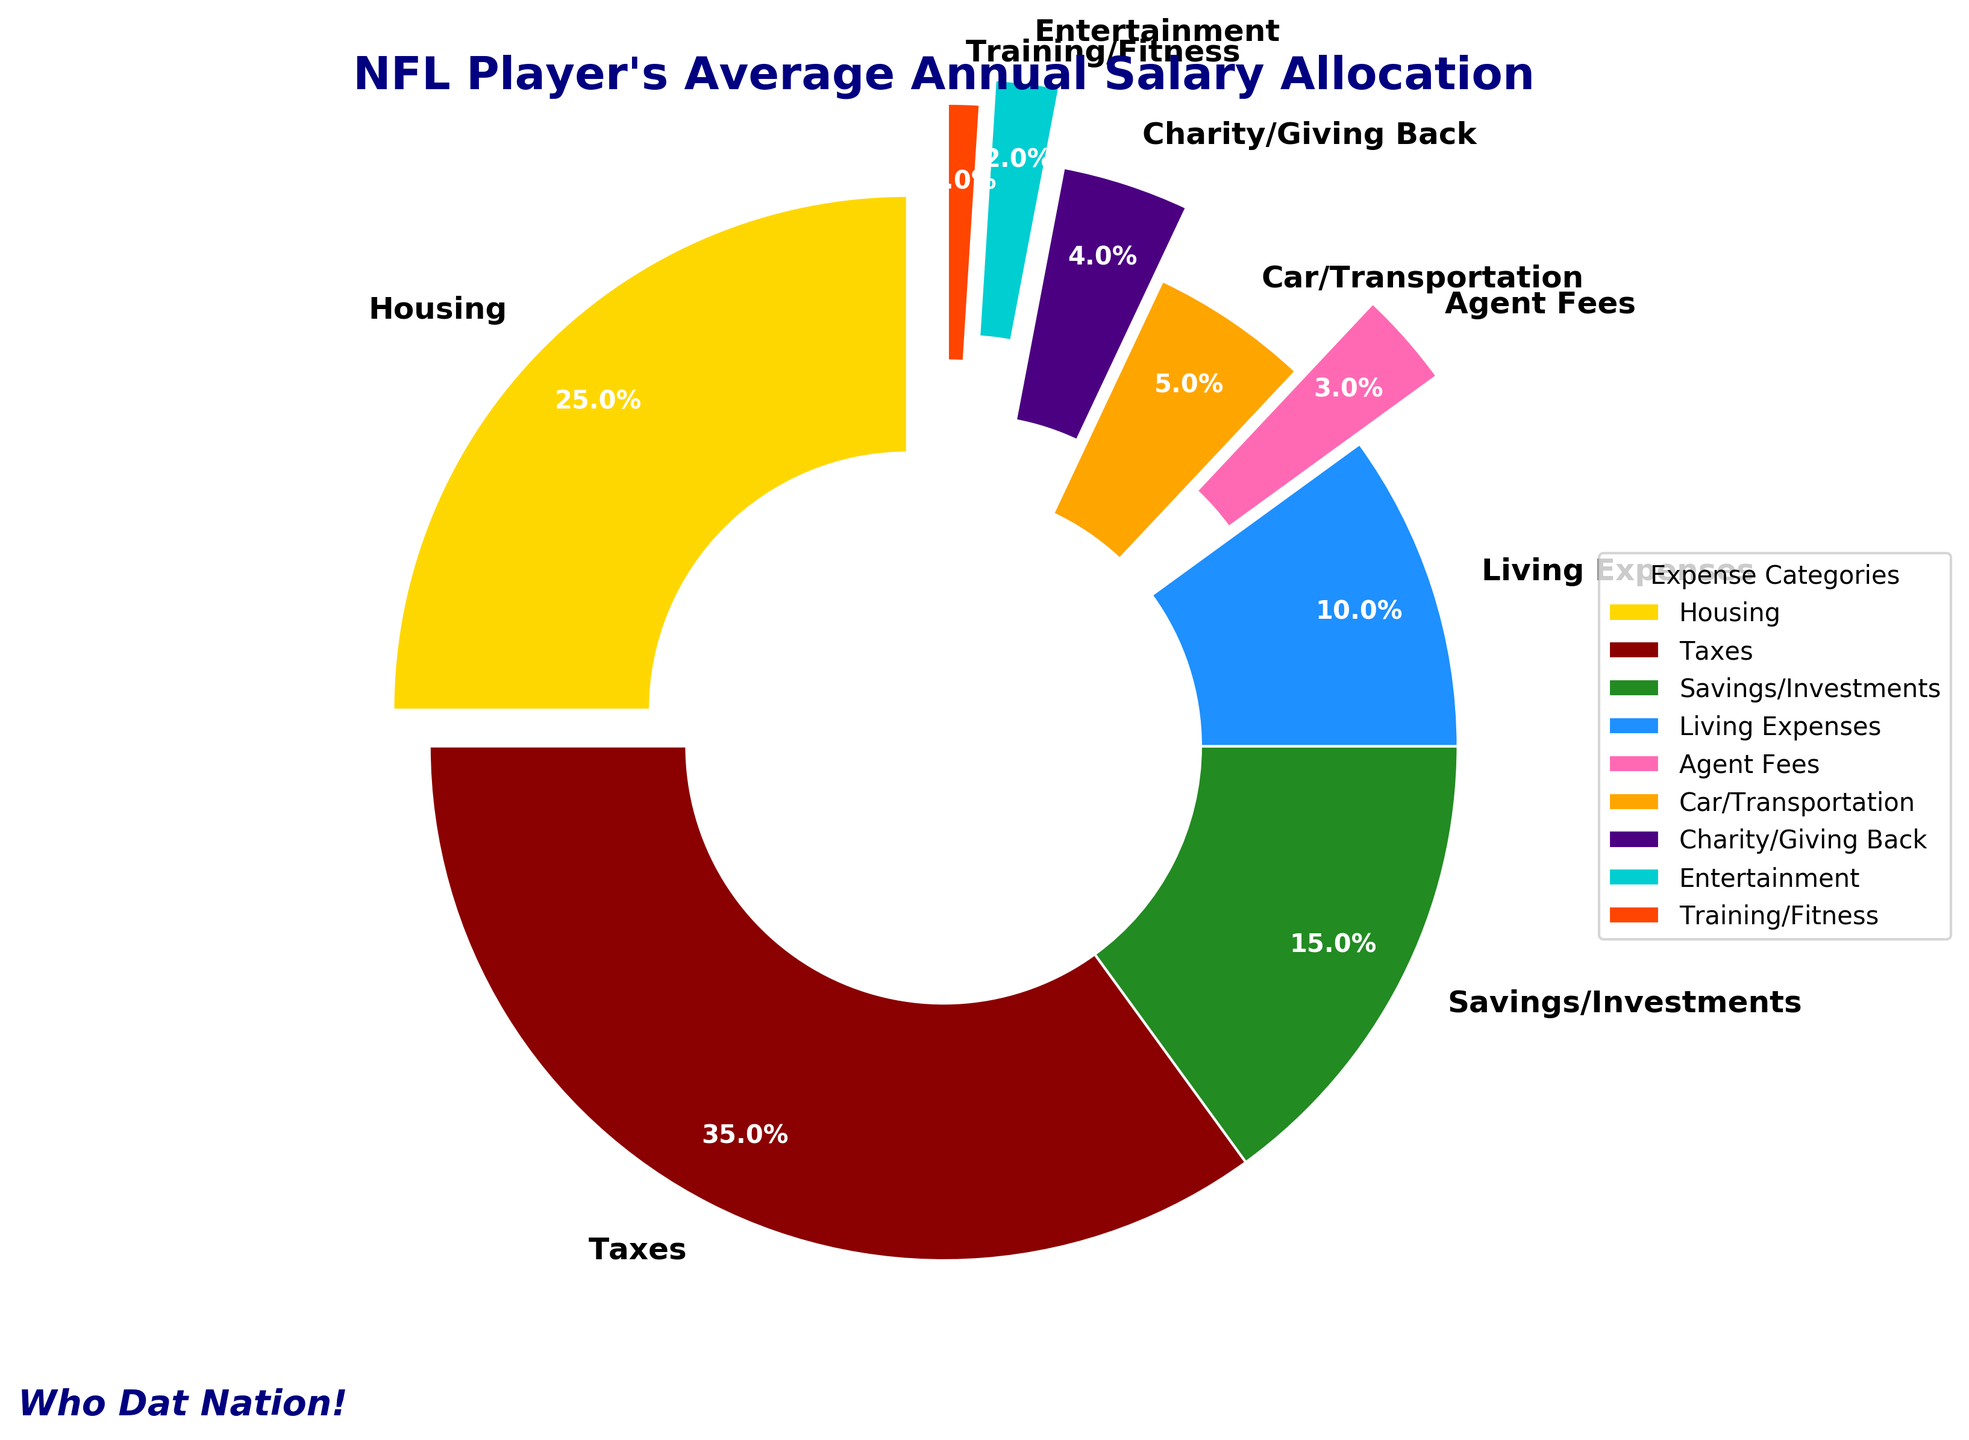What category has the highest percentage allocation? The pie chart shows different categories with their allocated percentages. The segment with the highest proportion is the Taxes category.
Answer: Taxes What is the sum of the allocations for the Housing and Savings/Investments categories? To find the sum, add the percentages of Housing and Savings/Investments. Housing is 25% and Savings/Investments is 15%, so the total is 25% + 15% = 40%.
Answer: 40% How much more is spent on Taxes than on Living Expenses? Subtract the percentage spent on Living Expenses from the percentage spent on Taxes. Taxes is 35% and Living Expenses is 10%, so the difference is 35% - 10% = 25%.
Answer: 25% Which category has the smallest percentage allocation? The pie chart depicts the Training/Fitness category as having the smallest segment.
Answer: Training/Fitness What is the combined allocation percentage for Charity/Giving Back, Entertainment, and Training/Fitness? Add the percentages of Charity/Giving Back, Entertainment, and Training/Fitness. They are 4%, 2%, and 1%, respectively, so the total is 4% + 2% + 1% = 7%.
Answer: 7% On which category is 5% of the salary spent? The pie chart shows that the Car/Transportation category is allocated 5%.
Answer: Car/Transportation What is the ratio of the allocation for Housing to the allocation for Agent Fees? The allocation for Housing is 25%, and for Agent Fees, it is 3%. The ratio is 25% / 3%. This simplifies to roughly 8.33:1.
Answer: 8.33:1 Which category is represented by a segment with a notable wider explosion than others? The segments in the pie chart with different explosion proportions reveal that Charity/Giving Back is considerably exploded out.
Answer: Charity/Giving Back By how much does the percentage allocation for Housing exceed that for Car/Transportation? Subtract the percentage allocated to Car/Transportation from that of Housing. Housing is allocated 25%, and Car/Transportation is 5%, so the difference is 25% - 5% = 20%.
Answer: 20% Which category's allocation is visually represented by a golden yellow color in the chart? The pie chart shows a segment colored in golden yellow, which corresponds to the Housing category.
Answer: Housing 